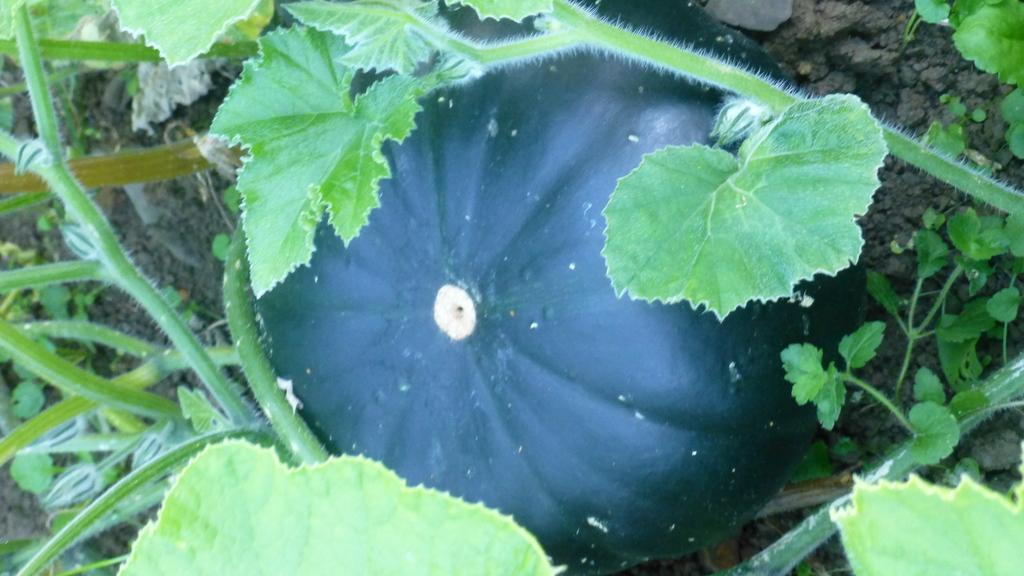What is located in the center of the image? There are plants in the center of the image. What type of vegetable can be seen in the image? There is a pumpkin in the image. What is the color of the pumpkin? The pumpkin is green in color. What type of jeans is the carpenter wearing while knitting with yarn in the image? There is no carpenter, jeans, or yarn present in the image. 